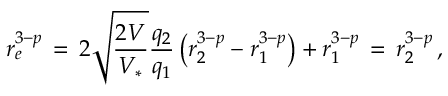<formula> <loc_0><loc_0><loc_500><loc_500>r _ { e } ^ { 3 - p } \, = \, 2 \sqrt { \frac { 2 V } { V _ { * } } } \frac { q _ { 2 } } { q _ { 1 } } \left ( r _ { 2 } ^ { 3 - p } - r _ { 1 } ^ { 3 - p } \right ) + r _ { 1 } ^ { 3 - p } \, = \, r _ { 2 } ^ { 3 - p } \, ,</formula> 